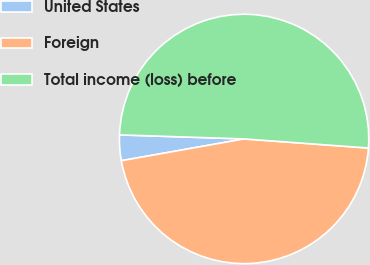Convert chart. <chart><loc_0><loc_0><loc_500><loc_500><pie_chart><fcel>United States<fcel>Foreign<fcel>Total income (loss) before<nl><fcel>3.31%<fcel>46.04%<fcel>50.64%<nl></chart> 